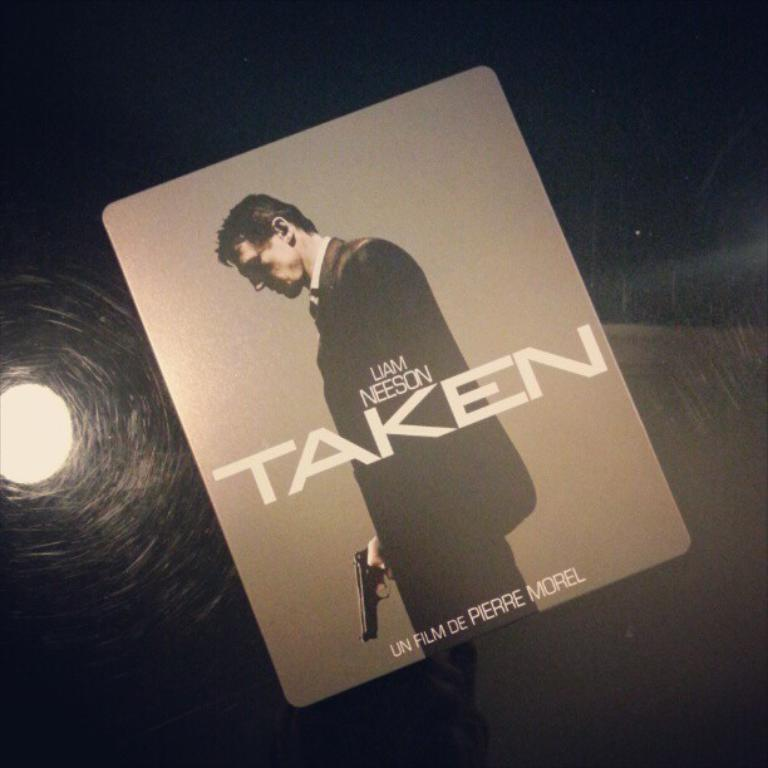What is present on the poster in the image? The poster contains text and an image. Can you describe the image on the poster? The details of the image on the poster are not provided, so we cannot describe it. Is there any light visible in the image? Yes, there is light visible behind the poster. What type of rock can be seen in the image? There is no rock present in the image; it features a poster with text and an image. What kind of waste is depicted in the image? There is no waste depicted in the image; it features a poster with text and an image. 